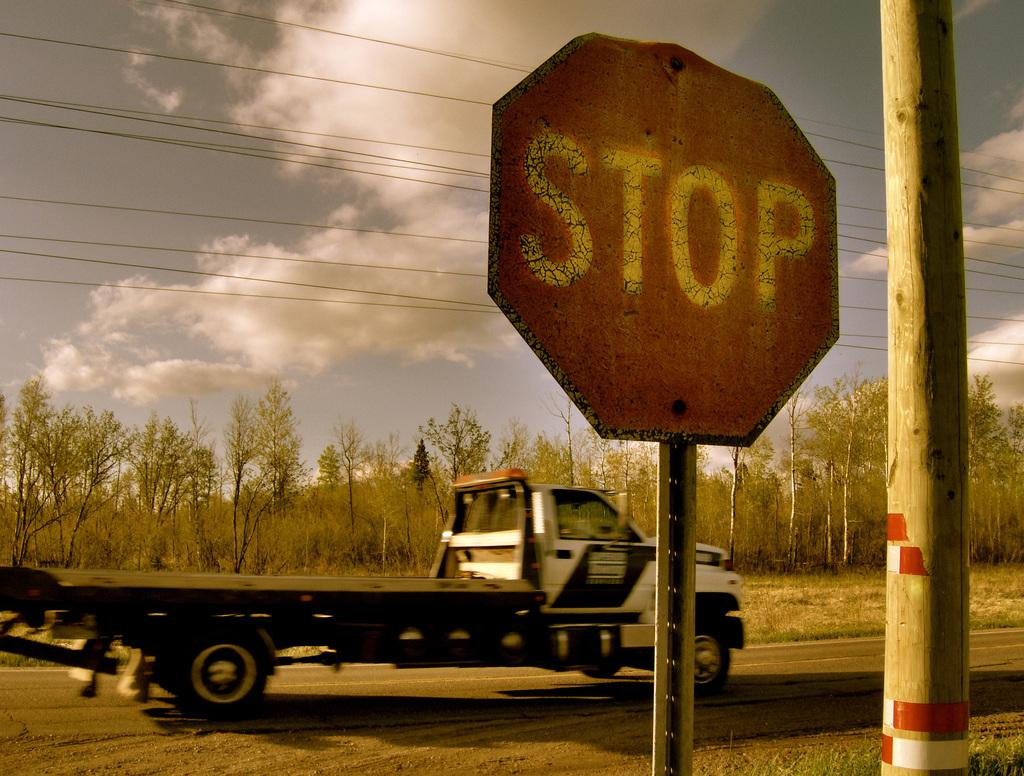<image>
Offer a succinct explanation of the picture presented. A tow truck with a flat bed is driving down a country road past an old stop sign next to a telephone pole. 